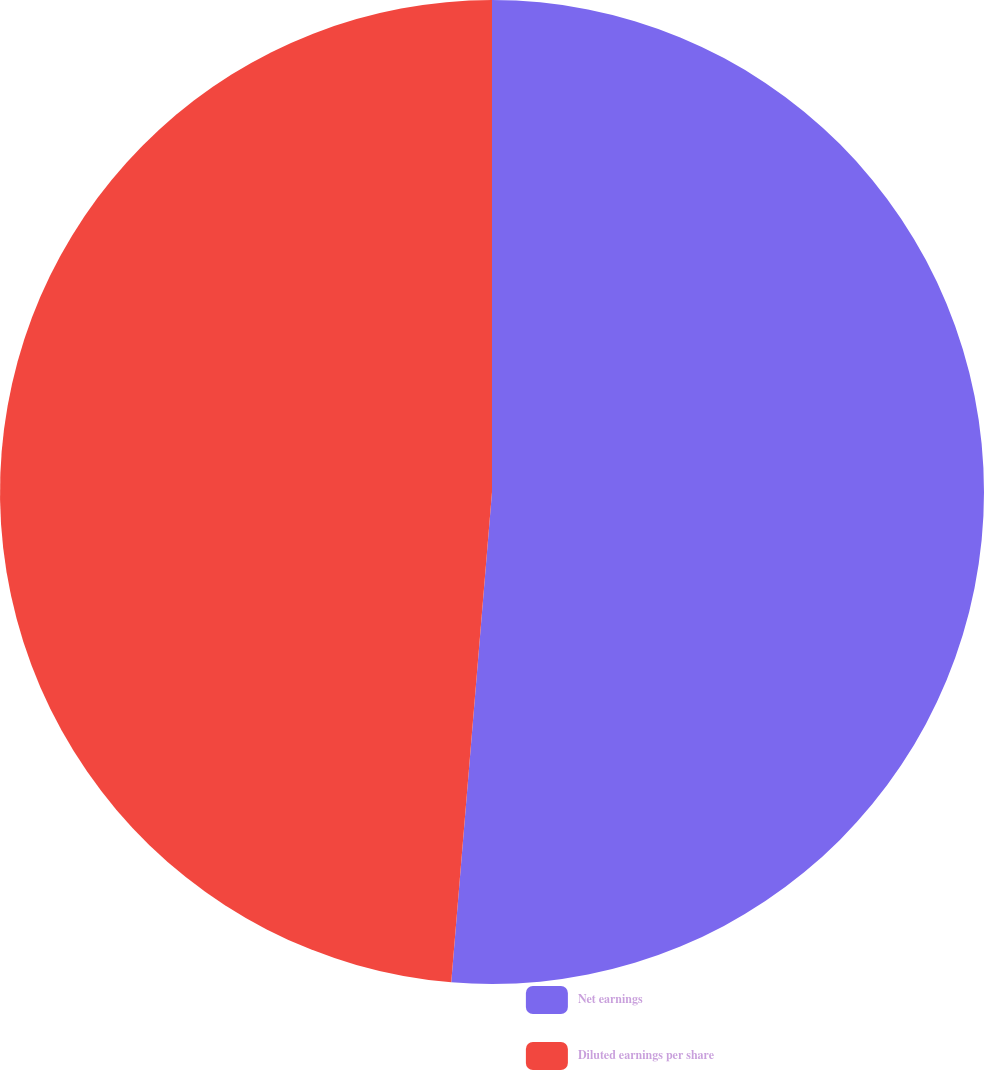Convert chart. <chart><loc_0><loc_0><loc_500><loc_500><pie_chart><fcel>Net earnings<fcel>Diluted earnings per share<nl><fcel>51.32%<fcel>48.68%<nl></chart> 